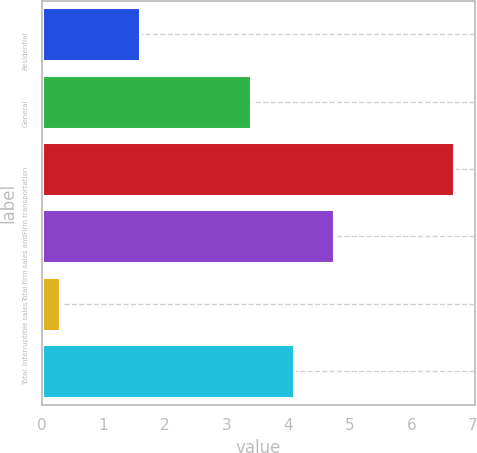Convert chart to OTSL. <chart><loc_0><loc_0><loc_500><loc_500><bar_chart><fcel>Residential<fcel>General<fcel>Firm transportation<fcel>Total firm sales and<fcel>Interruptible sales<fcel>Total<nl><fcel>1.6<fcel>3.4<fcel>6.7<fcel>4.74<fcel>0.3<fcel>4.1<nl></chart> 